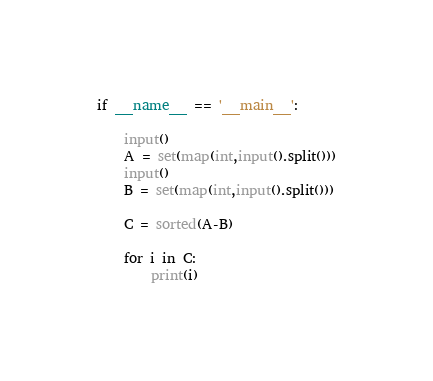Convert code to text. <code><loc_0><loc_0><loc_500><loc_500><_Python_>if __name__ == '__main__':

	input()
	A = set(map(int,input().split()))
	input()
	B = set(map(int,input().split()))

	C = sorted(A-B)

	for i in C:
		print(i)

</code> 